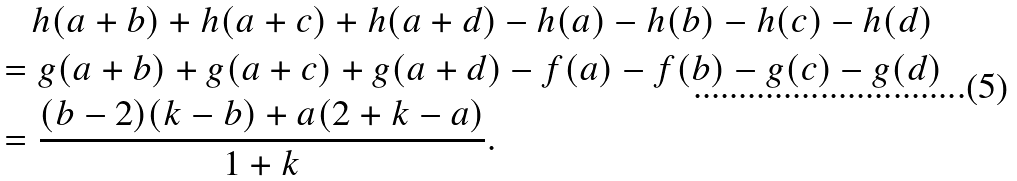<formula> <loc_0><loc_0><loc_500><loc_500>& \quad h ( a + b ) + h ( a + c ) + h ( a + d ) - h ( a ) - h ( b ) - h ( c ) - h ( d ) \\ & = g ( a + b ) + g ( a + c ) + g ( a + d ) - f ( a ) - f ( b ) - g ( c ) - g ( d ) \\ & = \frac { ( b - 2 ) ( k - b ) + a ( 2 + k - a ) } { 1 + k } .</formula> 